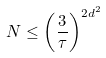Convert formula to latex. <formula><loc_0><loc_0><loc_500><loc_500>N \leq \left ( \frac { 3 } { \tau } \right ) ^ { 2 d ^ { 2 } }</formula> 